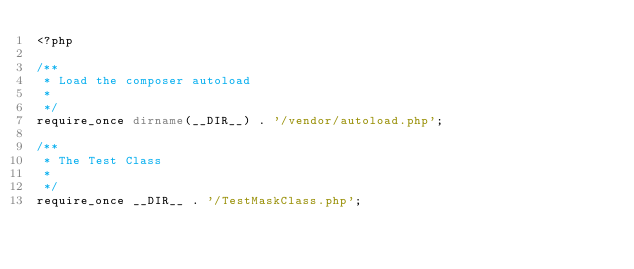Convert code to text. <code><loc_0><loc_0><loc_500><loc_500><_PHP_><?php

/**
 * Load the composer autoload
 *
 */
require_once dirname(__DIR__) . '/vendor/autoload.php';

/**
 * The Test Class
 *
 */
require_once __DIR__ . '/TestMaskClass.php';
</code> 